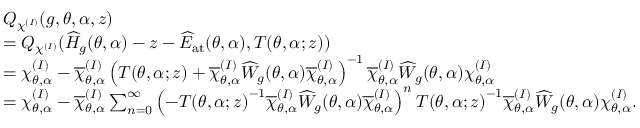<formula> <loc_0><loc_0><loc_500><loc_500>\begin{array} { r l } & { Q _ { \chi ^ { ( I ) } } ( g , \theta , \alpha , z ) } \\ & { = Q _ { \chi ^ { ( I ) } } ( \widehat { H } _ { g } ( \theta , \alpha ) - z - \widehat { E } _ { a t } ( \theta , \alpha ) , T ( \theta , \alpha ; z ) ) } \\ & { = \chi _ { \theta , \alpha } ^ { ( I ) } - \overline { \chi } _ { \theta , \alpha } ^ { ( I ) } \left ( T ( \theta , \alpha ; z ) + \overline { \chi } _ { \theta , \alpha } ^ { ( I ) } \widehat { W } _ { g } ( \theta , \alpha ) \overline { \chi } _ { \theta , \alpha } ^ { ( I ) } \right ) ^ { - 1 } \overline { \chi } _ { \theta , \alpha } ^ { ( I ) } \widehat { W } _ { g } ( \theta , \alpha ) \chi _ { \theta , \alpha } ^ { ( I ) } } \\ & { = \chi _ { \theta , \alpha } ^ { ( I ) } - \overline { \chi } _ { \theta , \alpha } ^ { ( I ) } \sum _ { n = 0 } ^ { \infty } \left ( - { T ( \theta , \alpha ; z ) } ^ { - 1 } \overline { \chi } _ { \theta , \alpha } ^ { ( I ) } \widehat { W } _ { g } ( \theta , \alpha ) \overline { \chi } _ { \theta , \alpha } ^ { ( I ) } \right ) ^ { n } { T ( \theta , \alpha ; z ) } ^ { - 1 } \overline { \chi } _ { \theta , \alpha } ^ { ( I ) } \widehat { W } _ { g } ( \theta , \alpha ) \chi _ { \theta , \alpha } ^ { ( I ) } . } \end{array}</formula> 